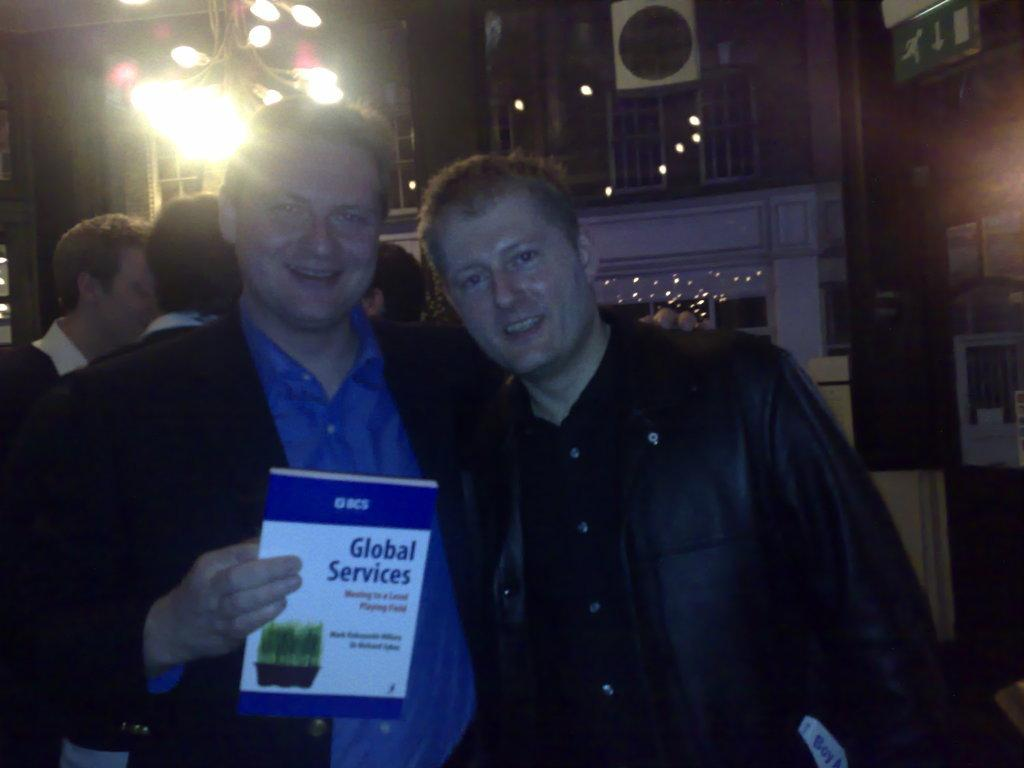Who can be seen in the image? There are people in the image. Can you describe the lighting conditions in the image? The image is a little dark. What is the position of the man in the image? A man is standing in the front of the image. What is the man holding in the image? The man is holding a book. What else can be seen in the image besides the people? There are lights visible in the image. What type of sail can be seen in the image? There is no sail present in the image. Can you describe the bite marks on the book in the image? There are no bite marks on the book in the image. Who is the writer of the book in the image? The image does not provide information about the writer of the book. 